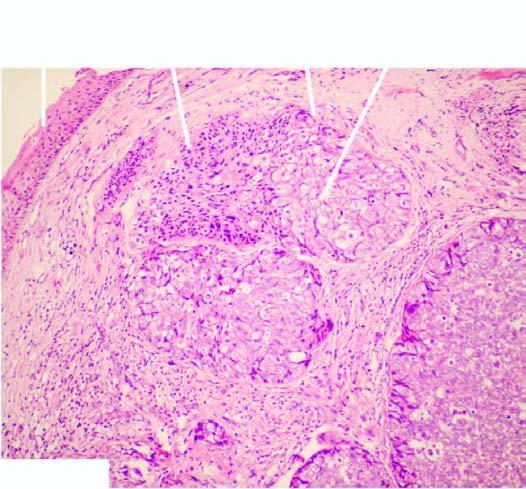what do the cells have?
Answer the question using a single word or phrase. Sebaceous differentiation appreciated by foamy 